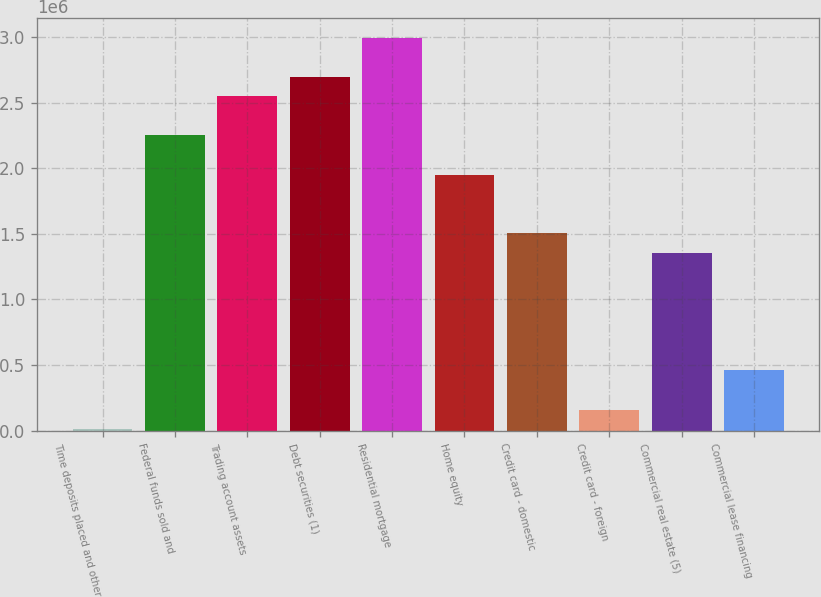<chart> <loc_0><loc_0><loc_500><loc_500><bar_chart><fcel>Time deposits placed and other<fcel>Federal funds sold and<fcel>Trading account assets<fcel>Debt securities (1)<fcel>Residential mortgage<fcel>Home equity<fcel>Credit card - domestic<fcel>Credit card - foreign<fcel>Commercial real estate (5)<fcel>Commercial lease financing<nl><fcel>10459<fcel>2.24927e+06<fcel>2.54778e+06<fcel>2.69703e+06<fcel>2.99554e+06<fcel>1.95076e+06<fcel>1.503e+06<fcel>159713<fcel>1.35374e+06<fcel>458221<nl></chart> 